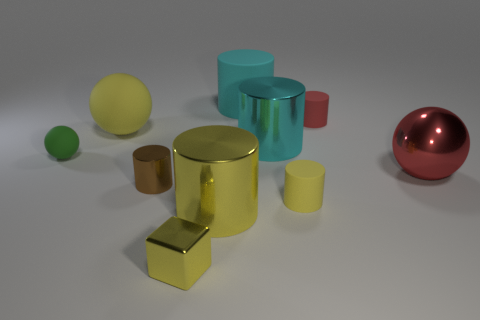Subtract all cyan cylinders. How many cylinders are left? 4 Subtract all brown cylinders. How many cylinders are left? 5 Subtract 3 cylinders. How many cylinders are left? 3 Subtract all purple cylinders. Subtract all red cubes. How many cylinders are left? 6 Subtract all cubes. How many objects are left? 9 Add 3 big green shiny cylinders. How many big green shiny cylinders exist? 3 Subtract 0 cyan cubes. How many objects are left? 10 Subtract all tiny shiny cylinders. Subtract all big metal balls. How many objects are left? 8 Add 2 large yellow cylinders. How many large yellow cylinders are left? 3 